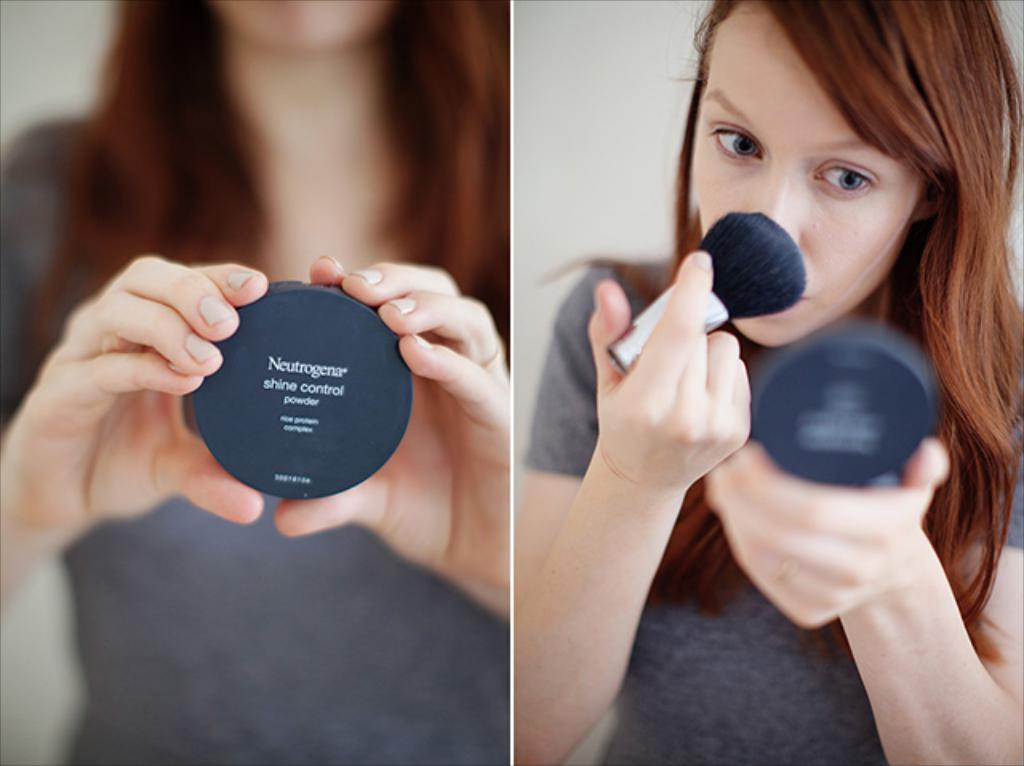Provide a one-sentence caption for the provided image. a girl with a large brush is applying Neutrogena shine control powder from a black compact. 